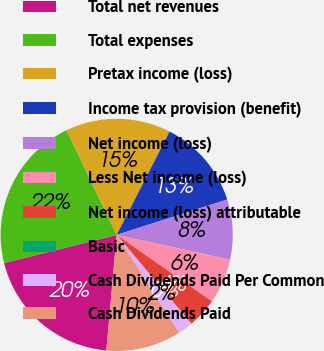Convert chart to OTSL. <chart><loc_0><loc_0><loc_500><loc_500><pie_chart><fcel>Total net revenues<fcel>Total expenses<fcel>Pretax income (loss)<fcel>Income tax provision (benefit)<fcel>Net income (loss)<fcel>Less Net income (loss)<fcel>Net income (loss) attributable<fcel>Basic<fcel>Cash Dividends Paid Per Common<fcel>Cash Dividends Paid<nl><fcel>19.7%<fcel>21.78%<fcel>14.63%<fcel>12.54%<fcel>8.36%<fcel>6.27%<fcel>4.18%<fcel>0.0%<fcel>2.09%<fcel>10.45%<nl></chart> 